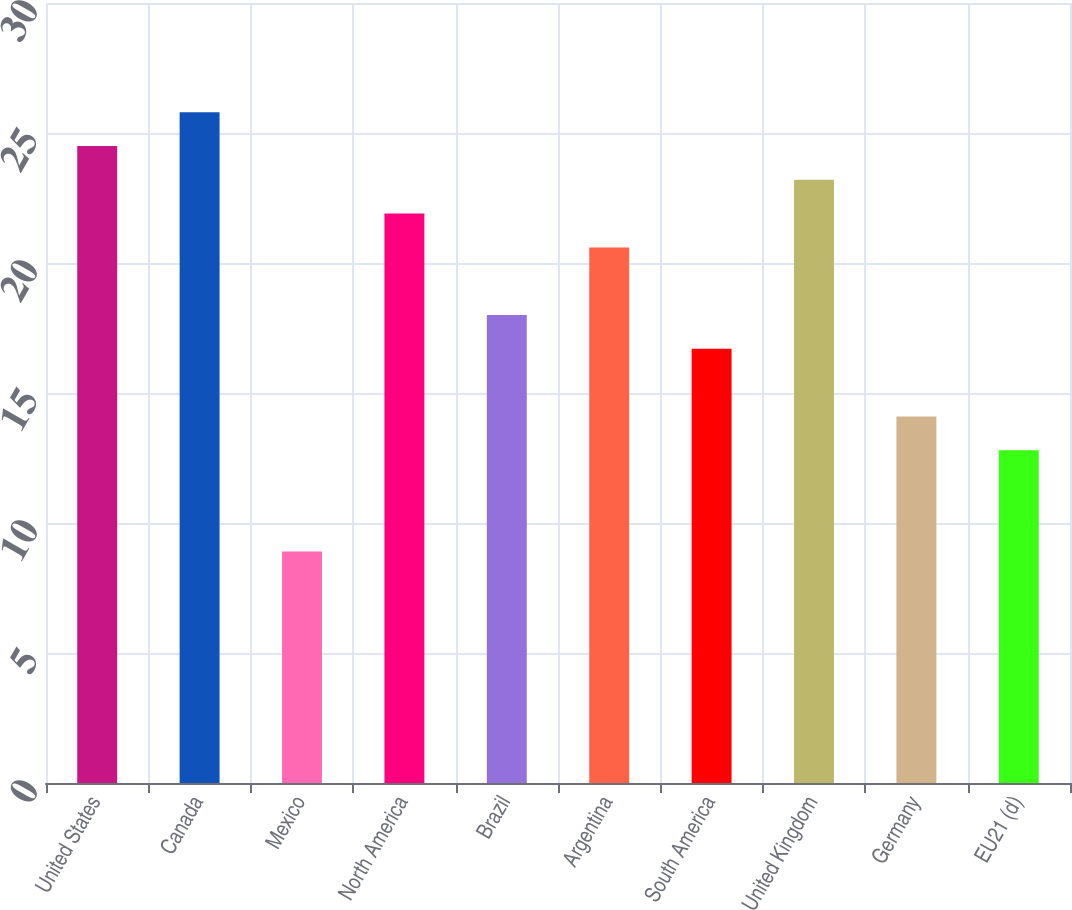<chart> <loc_0><loc_0><loc_500><loc_500><bar_chart><fcel>United States<fcel>Canada<fcel>Mexico<fcel>North America<fcel>Brazil<fcel>Argentina<fcel>South America<fcel>United Kingdom<fcel>Germany<fcel>EU21 (d)<nl><fcel>24.5<fcel>25.8<fcel>8.9<fcel>21.9<fcel>18<fcel>20.6<fcel>16.7<fcel>23.2<fcel>14.1<fcel>12.8<nl></chart> 